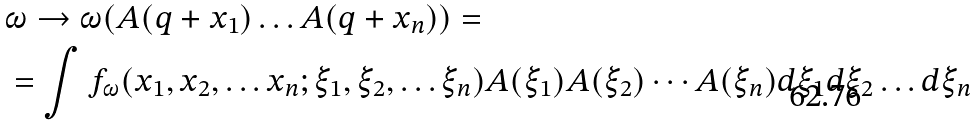<formula> <loc_0><loc_0><loc_500><loc_500>& \omega \rightarrow \omega ( A ( q + x _ { 1 } ) \dots A ( q + x _ { n } ) ) = \\ & = \int f _ { \omega } ( x _ { 1 } , x _ { 2 } , \dots x _ { n } ; \xi _ { 1 } , \xi _ { 2 } , \dots \xi _ { n } ) A ( \xi _ { 1 } ) A ( \xi _ { 2 } ) \cdots A ( \xi _ { n } ) d \xi _ { 1 } d \xi _ { 2 } \dots d \xi _ { n }</formula> 